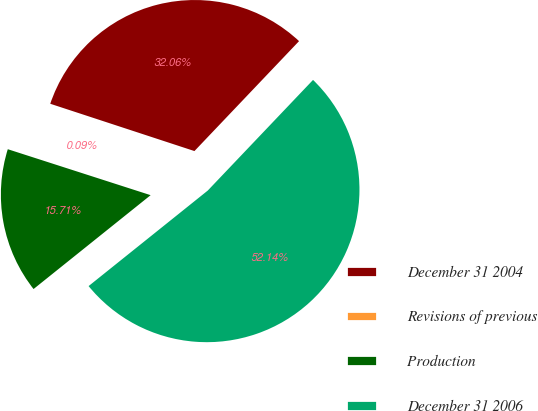Convert chart. <chart><loc_0><loc_0><loc_500><loc_500><pie_chart><fcel>December 31 2004<fcel>Revisions of previous<fcel>Production<fcel>December 31 2006<nl><fcel>32.06%<fcel>0.09%<fcel>15.71%<fcel>52.14%<nl></chart> 